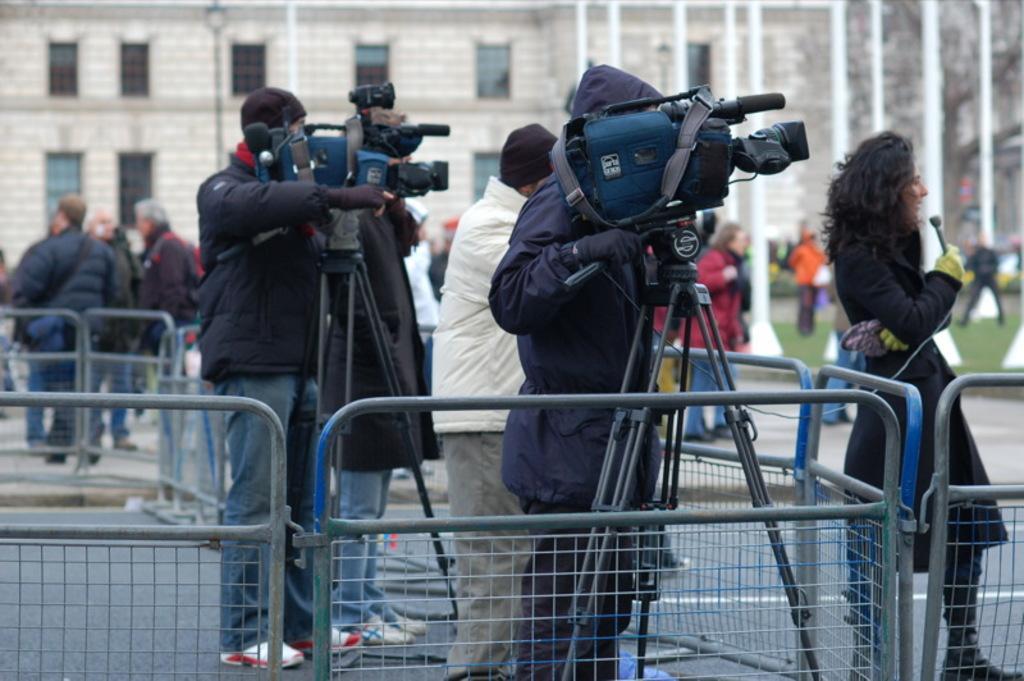Describe this image in one or two sentences. In this image I can see group of people standing. In front I can see two persons and they are holding cameras and they are wearing black color jackets. Background I can see few pillars, a light pole, a building in brown and white color and I can also see few windows. 